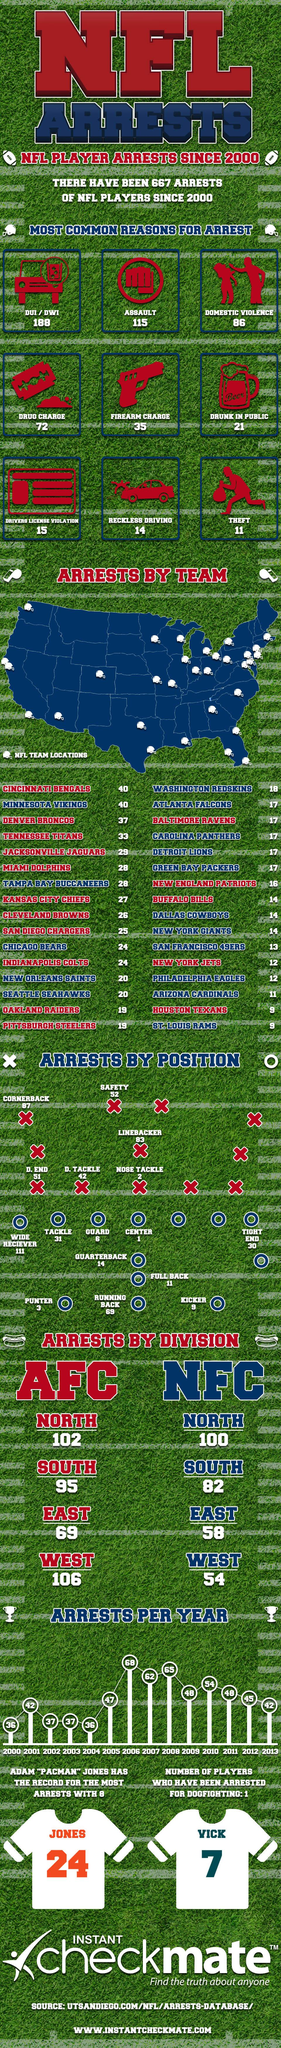Point out several critical features in this image. The number written on Jones' jersey is 24. Nine common reasons have been highlighted for the arrest. The number written on the jersey of Vick is 7. As of two arrests, the number of arrests by the nose tackle player is two. In 2008, the arrest was the second highest. 